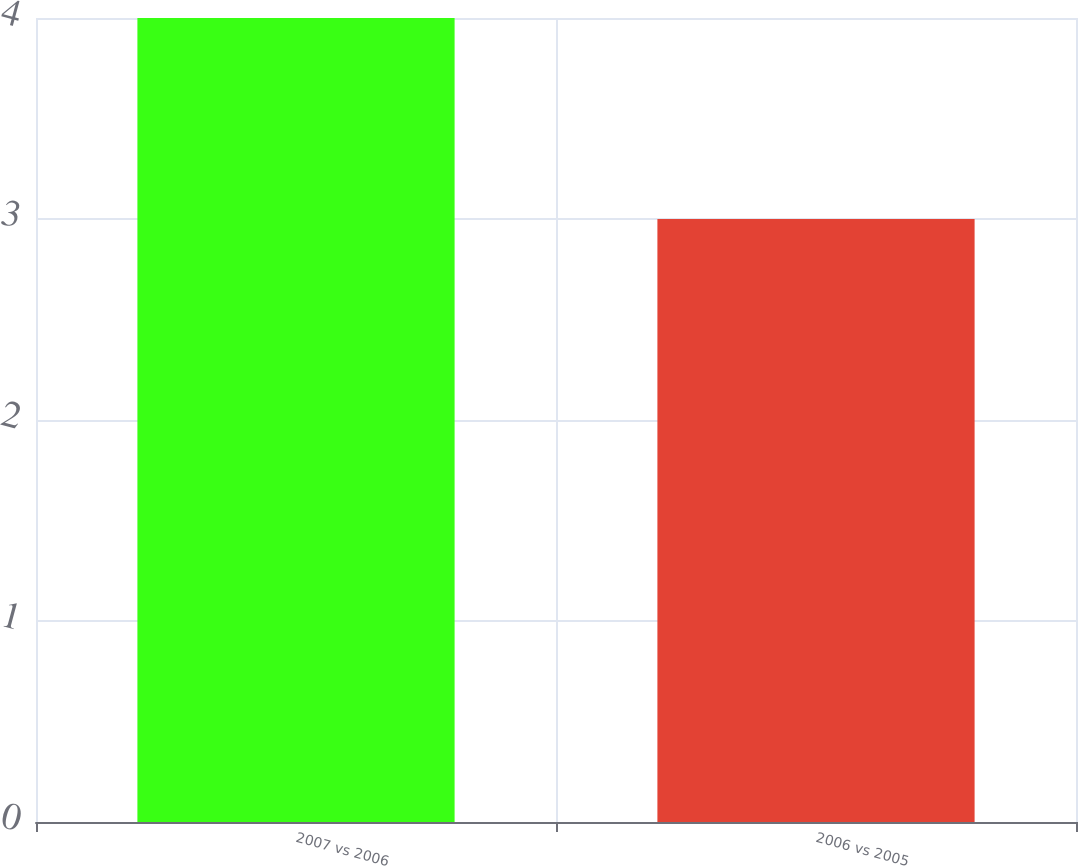<chart> <loc_0><loc_0><loc_500><loc_500><bar_chart><fcel>2007 vs 2006<fcel>2006 vs 2005<nl><fcel>4<fcel>3<nl></chart> 